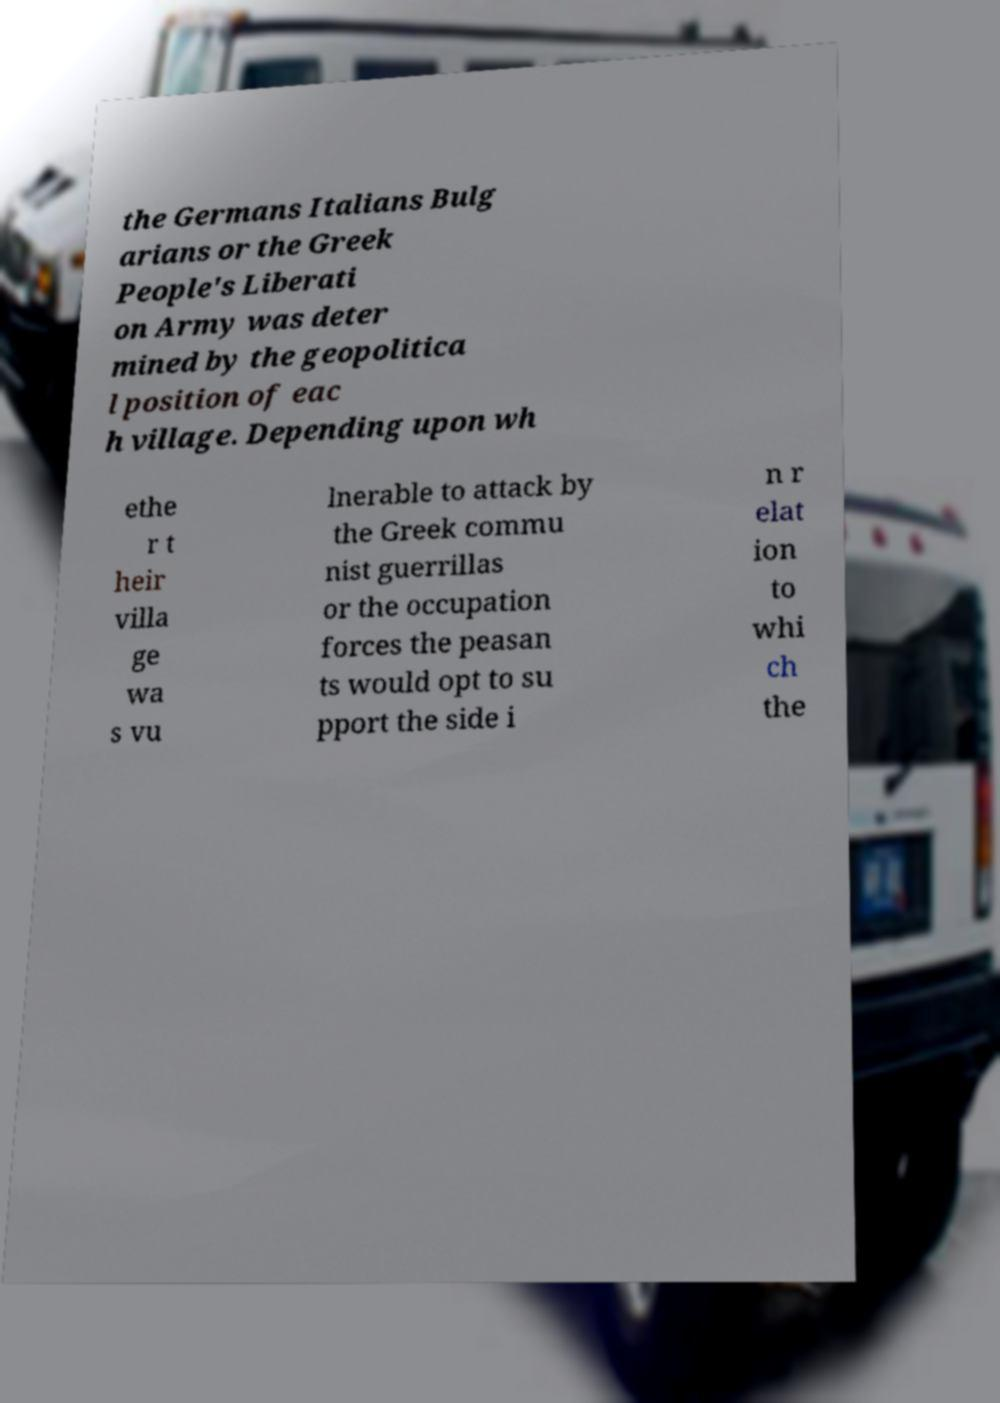What messages or text are displayed in this image? I need them in a readable, typed format. the Germans Italians Bulg arians or the Greek People's Liberati on Army was deter mined by the geopolitica l position of eac h village. Depending upon wh ethe r t heir villa ge wa s vu lnerable to attack by the Greek commu nist guerrillas or the occupation forces the peasan ts would opt to su pport the side i n r elat ion to whi ch the 